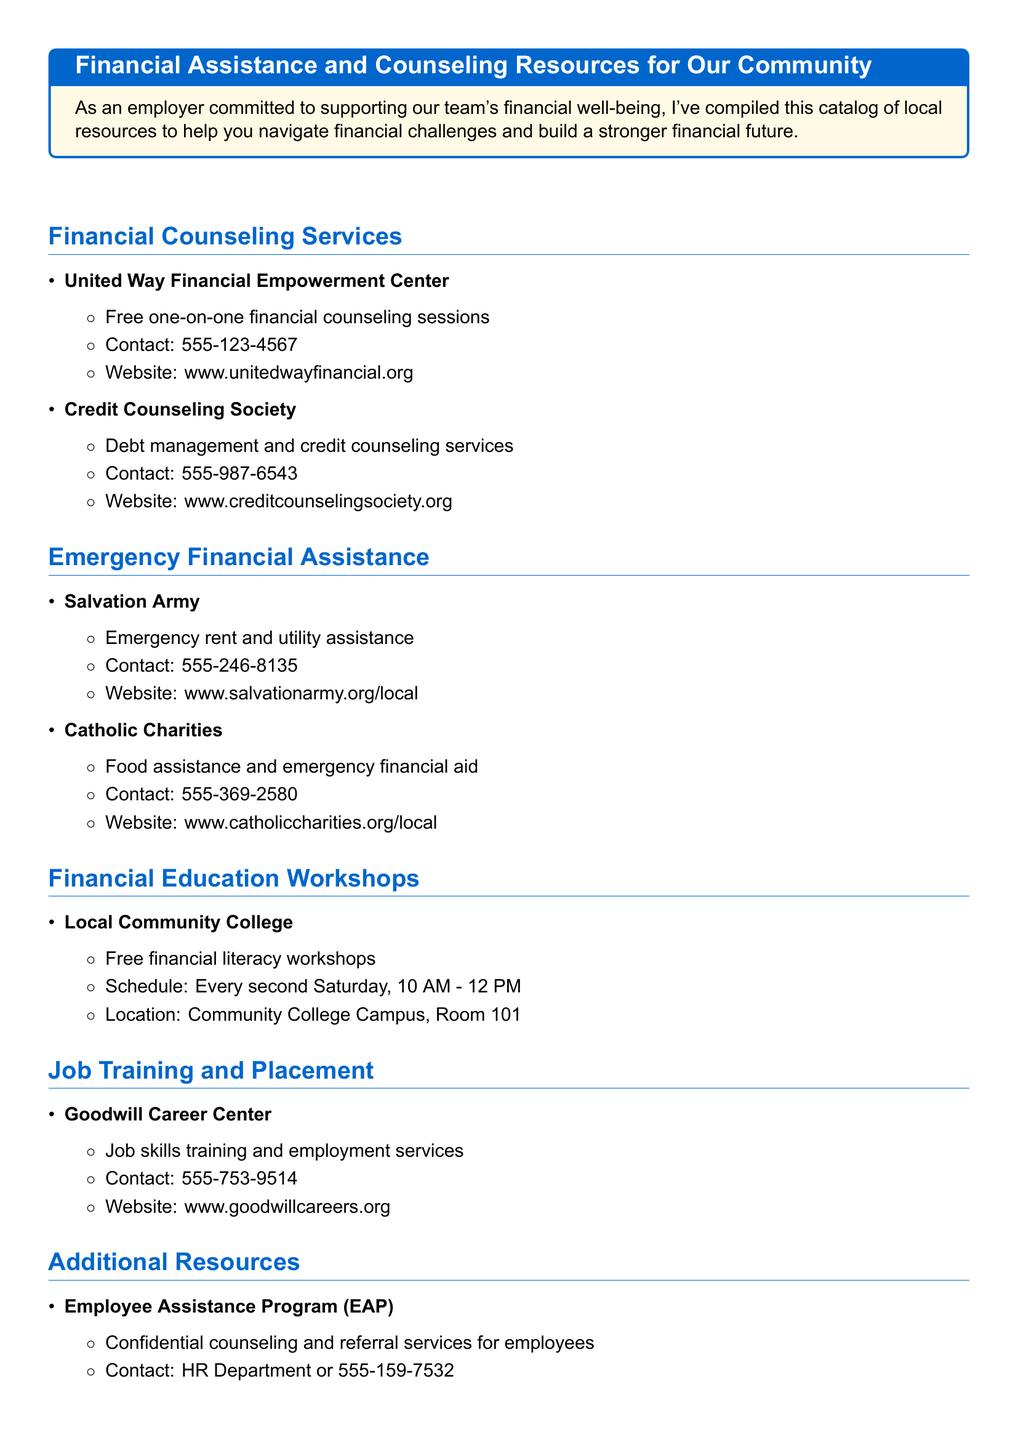What is the contact number for the United Way Financial Empowerment Center? The document lists the contact number as part of the details for the United Way Financial Empowerment Center.
Answer: 555-123-4567 Which organization provides emergency rent assistance? The document specifies that the Salvation Army offers emergency rent assistance within the section on Emergency Financial Assistance.
Answer: Salvation Army When are the free financial literacy workshops held? The document states the schedule for the financial literacy workshops provided by the Local Community College.
Answer: Every second Saturday, 10 AM - 12 PM What type of services does the Goodwill Career Center offer? The document mentions that the Goodwill Career Center provides job skills training and employment services.
Answer: Job skills training and employment services What is the website for Catholic Charities? The document includes the website address for Catholic Charities under the Emergency Financial Assistance section.
Answer: www.catholiccharities.org/local Which program offers confidential counseling for employees? The document identifies the Employee Assistance Program (EAP) as providing confidential counseling services for employees.
Answer: Employee Assistance Program (EAP) What type of assistance does the Credit Counseling Society provide? The document specifies that the Credit Counseling Society offers debt management and credit counseling services.
Answer: Debt management and credit counseling services How can someone contact the Credit Counseling Society? The document provides a contact number for the Credit Counseling Society, which is part of its details.
Answer: 555-987-6543 What is the location of the financial literacy workshops? The document states the location of the workshops held by the Local Community College.
Answer: Community College Campus, Room 101 